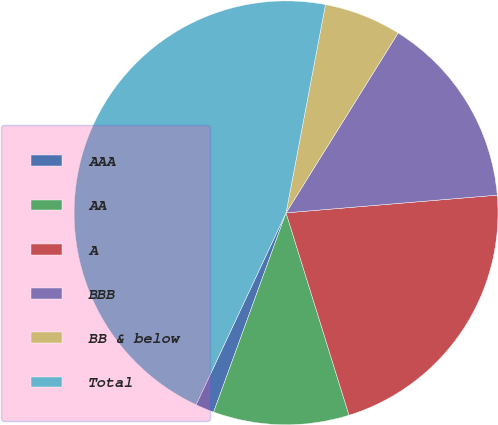Convert chart. <chart><loc_0><loc_0><loc_500><loc_500><pie_chart><fcel>AAA<fcel>AA<fcel>A<fcel>BBB<fcel>BB & below<fcel>Total<nl><fcel>1.43%<fcel>10.35%<fcel>21.53%<fcel>14.8%<fcel>5.89%<fcel>46.0%<nl></chart> 